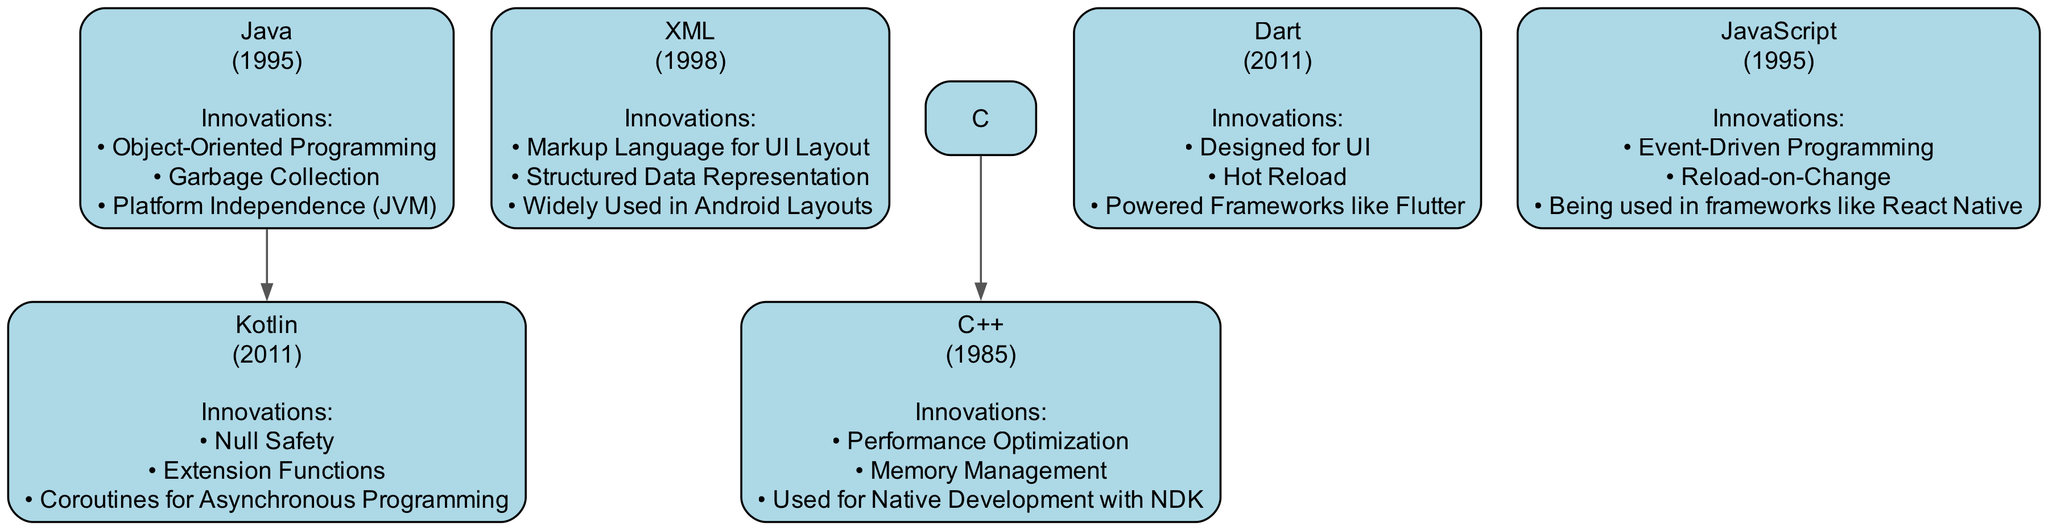What is the earliest programming language in the diagram? By looking at the nodes, I can see that "C++" was created in 1985, which is earlier than all the other languages listed in the diagram.
Answer: C++ Which language is a child of Java? In the diagram, the node for "Kotlin" is connected to "Java," indicating that Kotlin is a child language derived from Java.
Answer: Kotlin How many languages are listed in the diagram? There are a total of six languages shown in the diagram, including both parent and child nodes.
Answer: 6 What are the innovations introduced by Kotlin? By examining the node for "Kotlin," I find three innovations listed: Null Safety, Extension Functions, and Coroutines for Asynchronous Programming.
Answer: Null Safety, Extension Functions, Coroutines for Asynchronous Programming Which programming language introduced Hot Reload? Looking at the node for "Dart," I can see it lists "Hot Reload" as one of its innovations, indicating that Dart is the language that introduced this feature.
Answer: Dart What is the relationship between C and C++ in this diagram? In the diagram, there is a directed edge from "C" to "C++," indicating that C++ is derived from C, establishing C as a parent language.
Answer: Parent-child relationship What year was XML created? The label for the "XML" node indicates that it was created in 1998. Thus, the year directly states the time of its introduction.
Answer: 1998 Which language is primarily used for UI development in the Android ecosystem? By evaluating the purpose and innovations of "Dart," I see that it was designed for UI, making it the main language for UI development in this context.
Answer: Dart How many innovations are listed under Java? On the node for "Java," there are three innovations highlighted: Object-Oriented Programming, Garbage Collection, and Platform Independence (JVM), making a total of three innovations for this language.
Answer: 3 